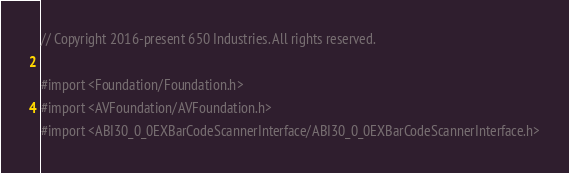Convert code to text. <code><loc_0><loc_0><loc_500><loc_500><_C_>// Copyright 2016-present 650 Industries. All rights reserved.

#import <Foundation/Foundation.h>
#import <AVFoundation/AVFoundation.h>
#import <ABI30_0_0EXBarCodeScannerInterface/ABI30_0_0EXBarCodeScannerInterface.h>
</code> 